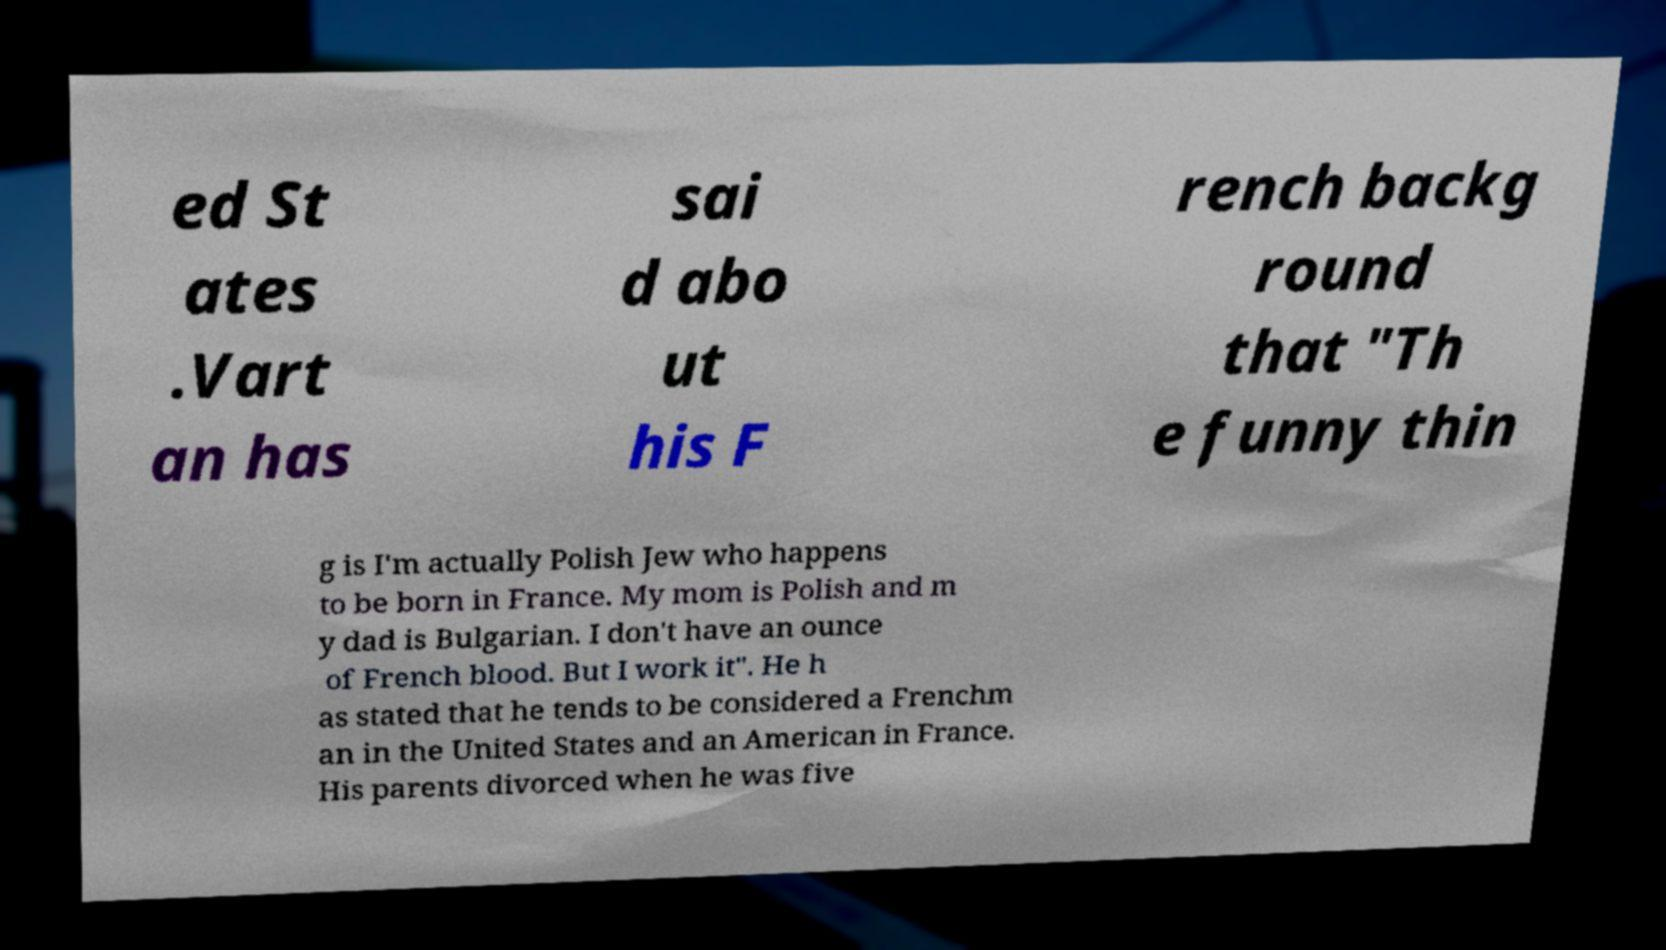Could you assist in decoding the text presented in this image and type it out clearly? ed St ates .Vart an has sai d abo ut his F rench backg round that "Th e funny thin g is I'm actually Polish Jew who happens to be born in France. My mom is Polish and m y dad is Bulgarian. I don't have an ounce of French blood. But I work it". He h as stated that he tends to be considered a Frenchm an in the United States and an American in France. His parents divorced when he was five 